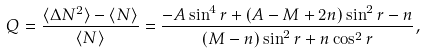<formula> <loc_0><loc_0><loc_500><loc_500>Q = \frac { \langle \Delta N ^ { 2 } \rangle - \langle N \rangle } { \langle N \rangle } = \frac { - A \sin ^ { 4 } r + ( A - M + 2 n ) \sin ^ { 2 } r - n } { ( M - n ) \sin ^ { 2 } r + n \cos ^ { 2 } r } ,</formula> 